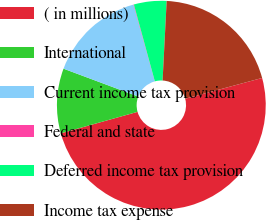Convert chart. <chart><loc_0><loc_0><loc_500><loc_500><pie_chart><fcel>( in millions)<fcel>International<fcel>Current income tax provision<fcel>Federal and state<fcel>Deferred income tax provision<fcel>Income tax expense<nl><fcel>49.87%<fcel>10.03%<fcel>15.01%<fcel>0.07%<fcel>5.05%<fcel>19.99%<nl></chart> 